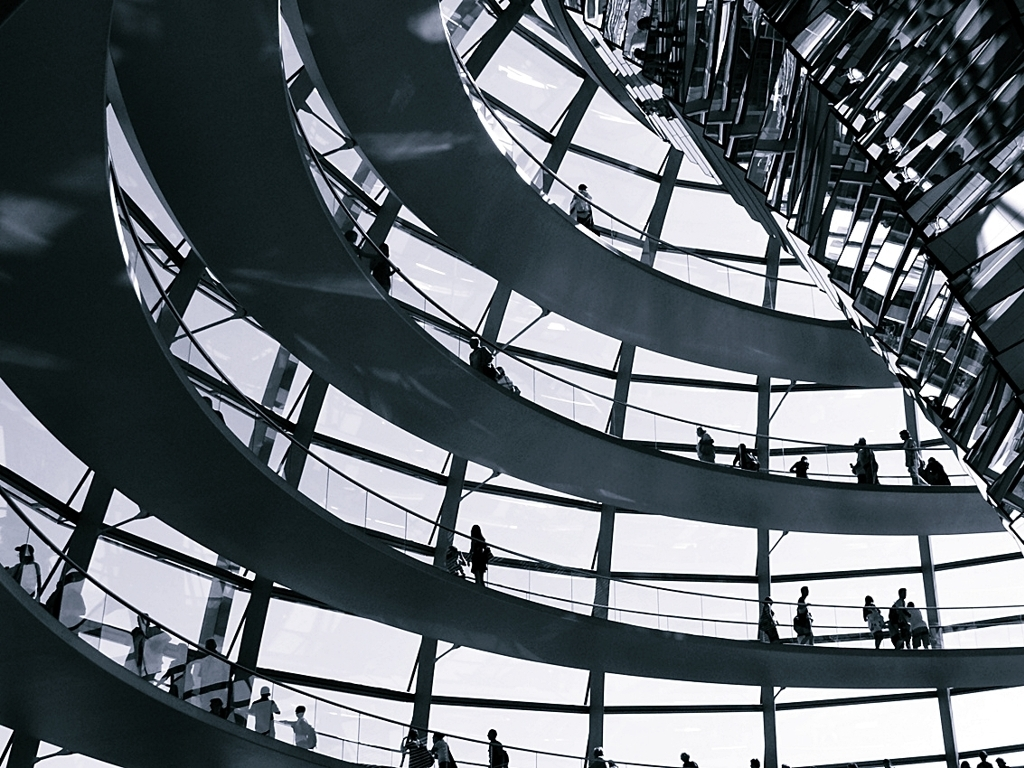Is the image sharp? While the image appears to have a good level of detail and the structural elements are crisp, the individuals are not in sharp focus, giving the photograph a soft quality that emphasizes the architecture over the people. 